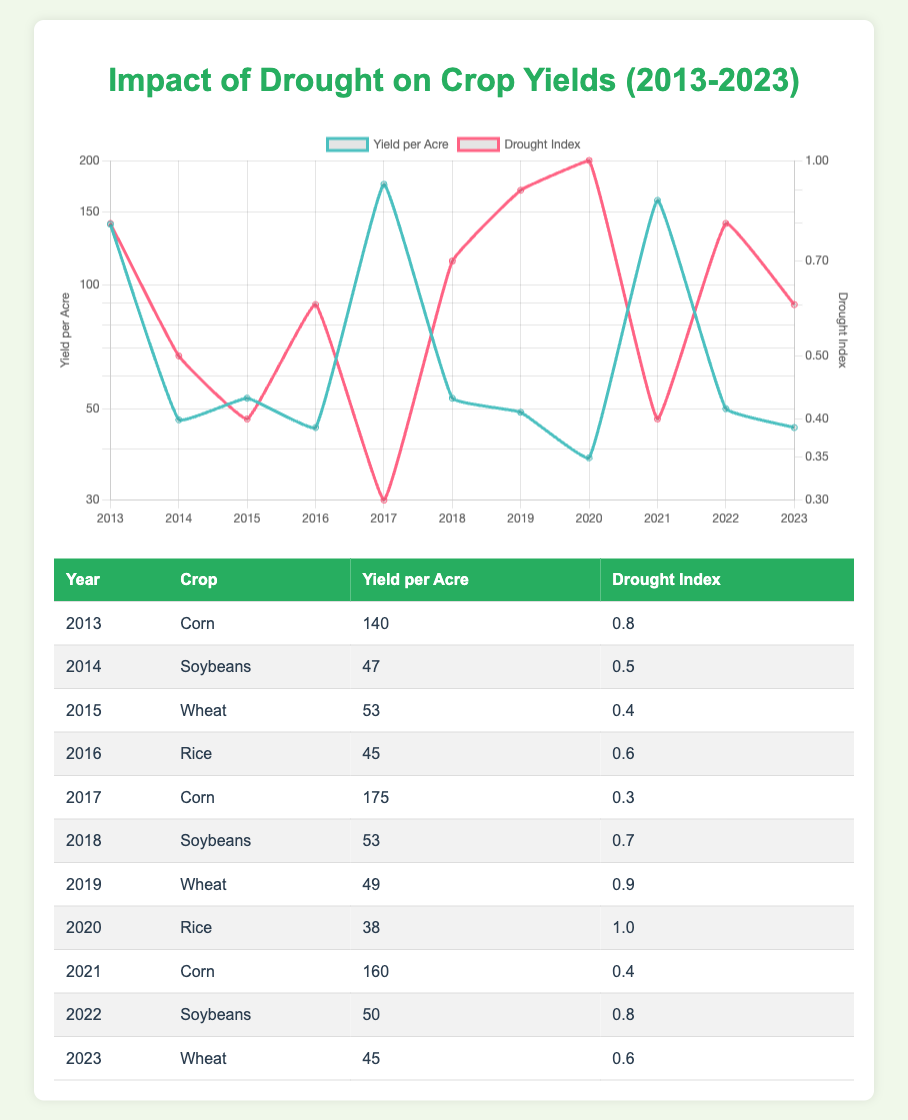What was the yield per acre for Corn in 2013? The table shows the row for the year 2013 and the crop Corn, listing the yield per acre as 140.
Answer: 140 Which crop had the lowest yield per acre during the decade? By examining the yield per acre for each crop, the lowest value is found in the year 2020 for Rice, which had a yield of 38.
Answer: 38 What is the average yield per acre for Soybeans from 2014 to 2022? The yields for Soybeans in those years are: 47 (2014), 53 (2018), and 50 (2022). The total sum is 47 + 53 + 50 = 150. There are 3 data points, so the average is 150 / 3 = 50.
Answer: 50 Did the drought index exceed 0.9 for any crop in the table? Looking through the drought index values, in 2019 the drought index for Wheat was 0.9, and in 2020 it reached 1.0, which means it did exceed 0.9.
Answer: Yes What was the change in yield per acre for Wheat from 2015 to 2023? The yield for Wheat in 2015 was 53 and in 2023 was 45. The change is 45 - 53 = -8, indicating a decrease.
Answer: -8 Which crop had the highest yield per acre and what was its drought index? The highest yield per acre is 175 for Corn in 2017. Its corresponding drought index is 0.3.
Answer: Corn, 0.3 What is the total yield per acre for all crops in 2016? In 2016, there was only one crop reported: Rice with a yield of 45 per acre. Since only one value exists, the total yield is simply 45.
Answer: 45 How many years did Corn have a yield greater than 150? By reviewing the data, Corn had yields greater than 150 in 2017 (175) and 2021 (160), totaling 2 years.
Answer: 2 What was the maximum drought index value recorded and in which year? The maximum drought index value observed in the table is 1.0, recorded in the year 2020 for Rice.
Answer: 1.0, 2020 